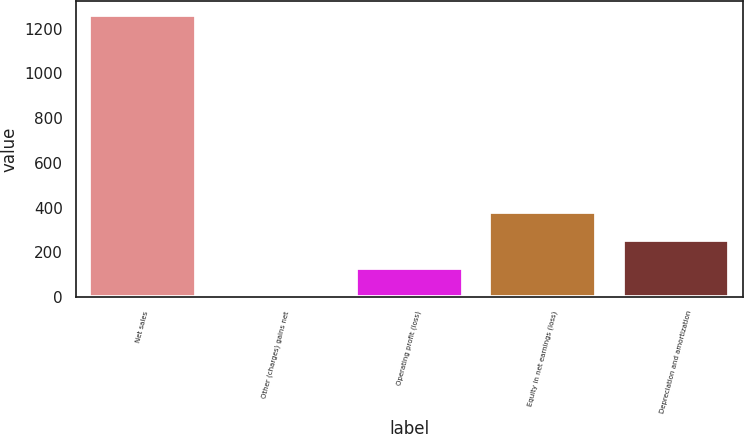Convert chart to OTSL. <chart><loc_0><loc_0><loc_500><loc_500><bar_chart><fcel>Net sales<fcel>Other (charges) gains net<fcel>Operating profit (loss)<fcel>Equity in net earnings (loss)<fcel>Depreciation and amortization<nl><fcel>1261<fcel>2<fcel>127.9<fcel>379.7<fcel>253.8<nl></chart> 